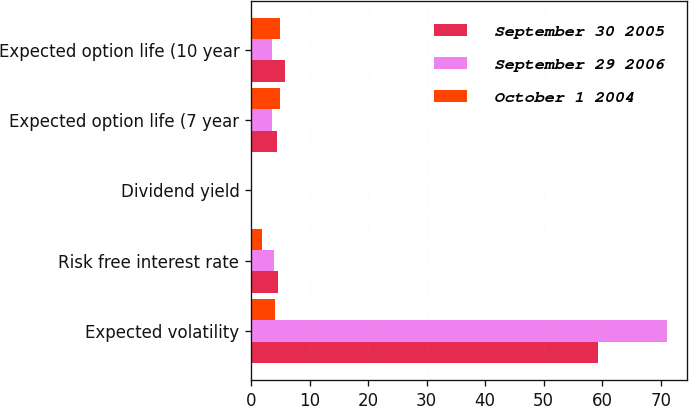<chart> <loc_0><loc_0><loc_500><loc_500><stacked_bar_chart><ecel><fcel>Expected volatility<fcel>Risk free interest rate<fcel>Dividend yield<fcel>Expected option life (7 year<fcel>Expected option life (10 year<nl><fcel>September 30 2005<fcel>59.27<fcel>4.55<fcel>0<fcel>4.42<fcel>5.84<nl><fcel>September 29 2006<fcel>71<fcel>3.9<fcel>0<fcel>3.5<fcel>3.5<nl><fcel>October 1 2004<fcel>4.16<fcel>1.9<fcel>0<fcel>5<fcel>5<nl></chart> 